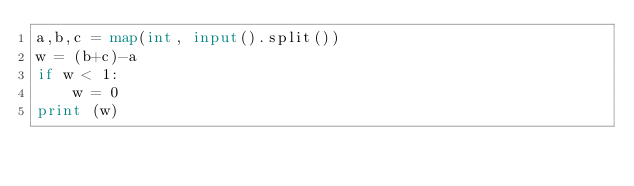Convert code to text. <code><loc_0><loc_0><loc_500><loc_500><_Python_>a,b,c = map(int, input().split())
w = (b+c)-a
if w < 1:
    w = 0
print (w)</code> 